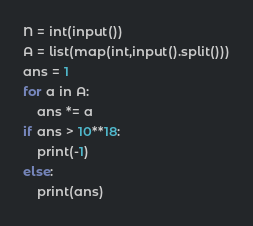Convert code to text. <code><loc_0><loc_0><loc_500><loc_500><_Python_>N = int(input())
A = list(map(int,input().split()))
ans = 1
for a in A:
    ans *= a
if ans > 10**18:
    print(-1)
else:
    print(ans)
</code> 